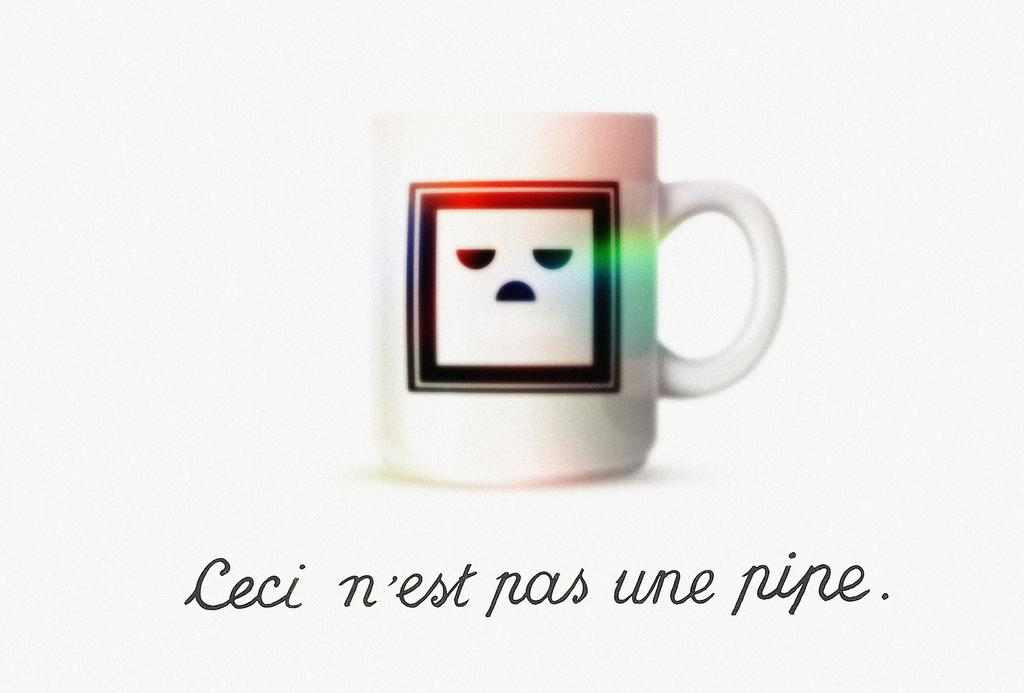<image>
Offer a succinct explanation of the picture presented. A mug with a sad face on it says,"Ceci n'est pas une pipe" underneath it. 